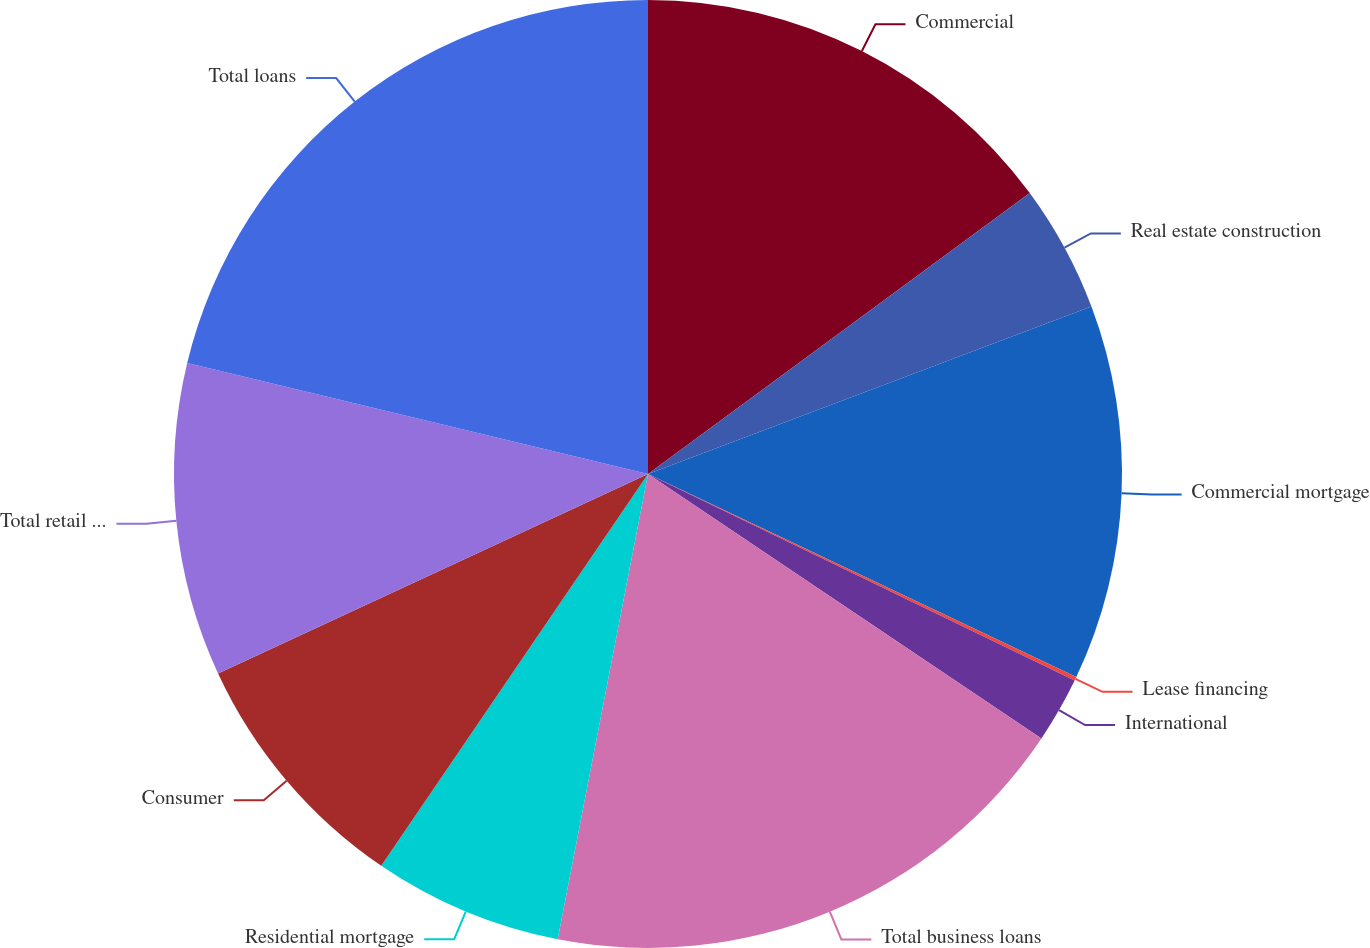Convert chart to OTSL. <chart><loc_0><loc_0><loc_500><loc_500><pie_chart><fcel>Commercial<fcel>Real estate construction<fcel>Commercial mortgage<fcel>Lease financing<fcel>International<fcel>Total business loans<fcel>Residential mortgage<fcel>Consumer<fcel>Total retail loans<fcel>Total loans<nl><fcel>14.9%<fcel>4.35%<fcel>12.79%<fcel>0.13%<fcel>2.24%<fcel>18.63%<fcel>6.46%<fcel>8.57%<fcel>10.68%<fcel>21.23%<nl></chart> 